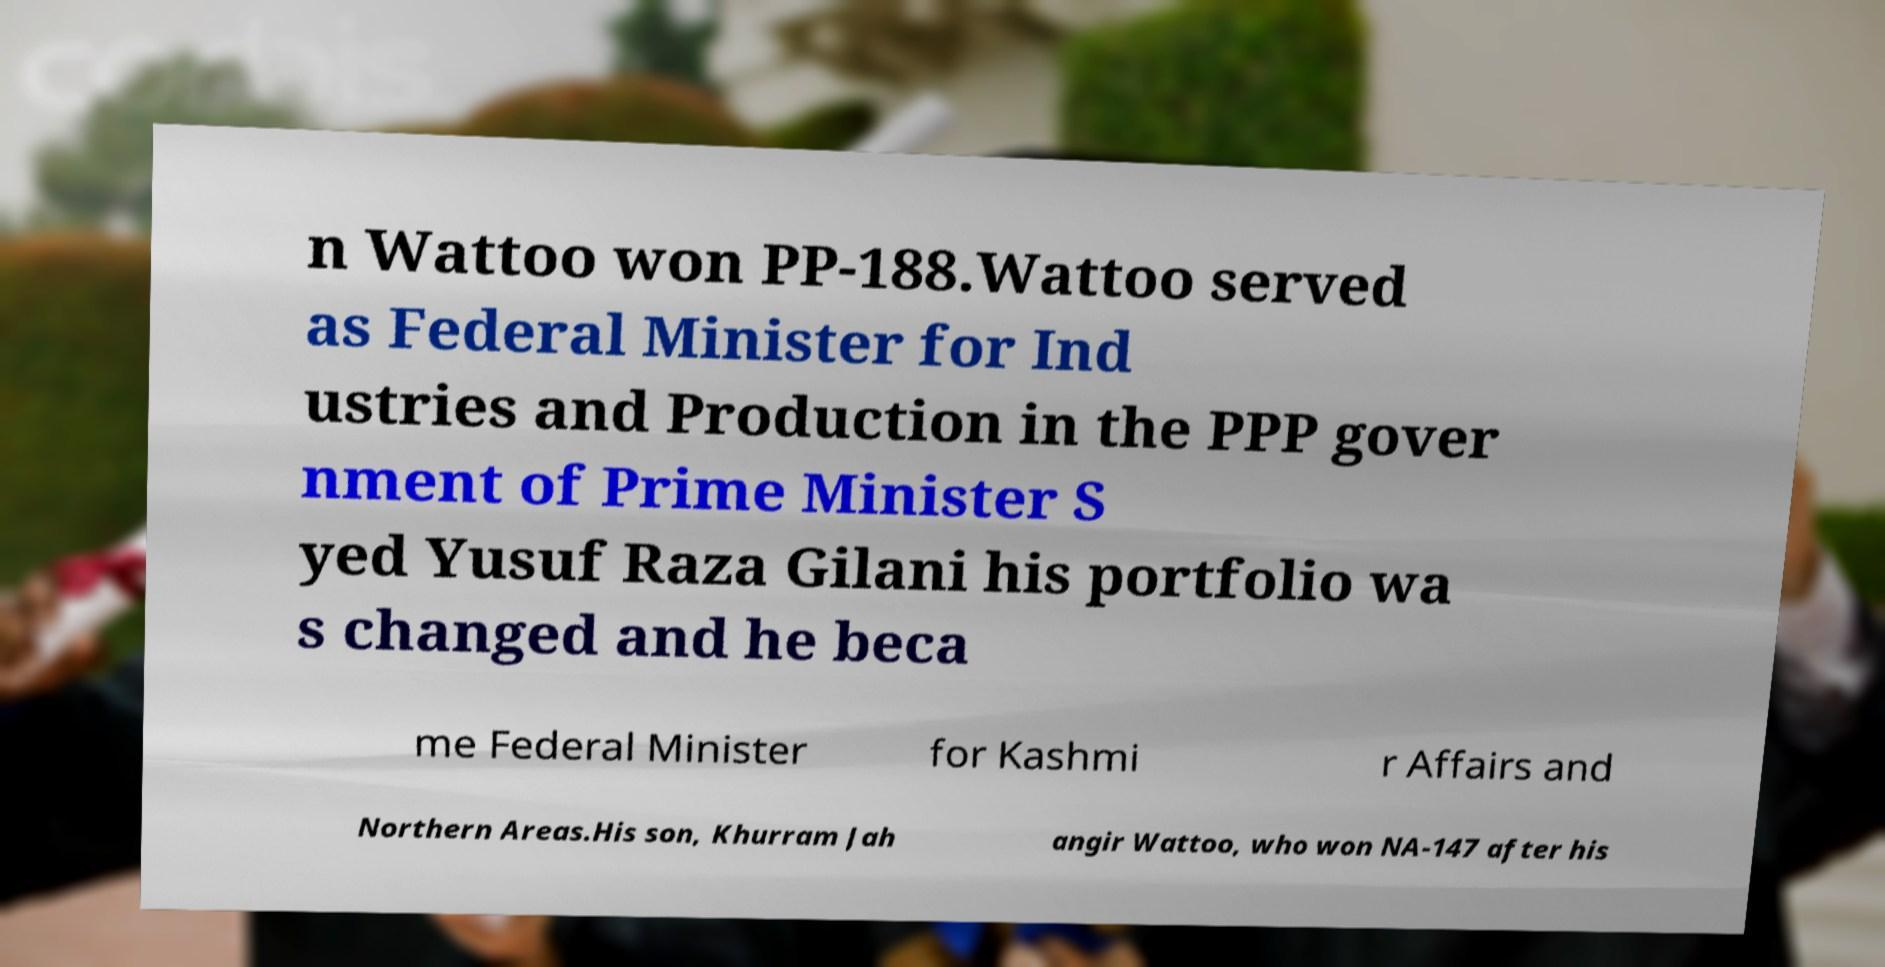I need the written content from this picture converted into text. Can you do that? n Wattoo won PP-188.Wattoo served as Federal Minister for Ind ustries and Production in the PPP gover nment of Prime Minister S yed Yusuf Raza Gilani his portfolio wa s changed and he beca me Federal Minister for Kashmi r Affairs and Northern Areas.His son, Khurram Jah angir Wattoo, who won NA-147 after his 